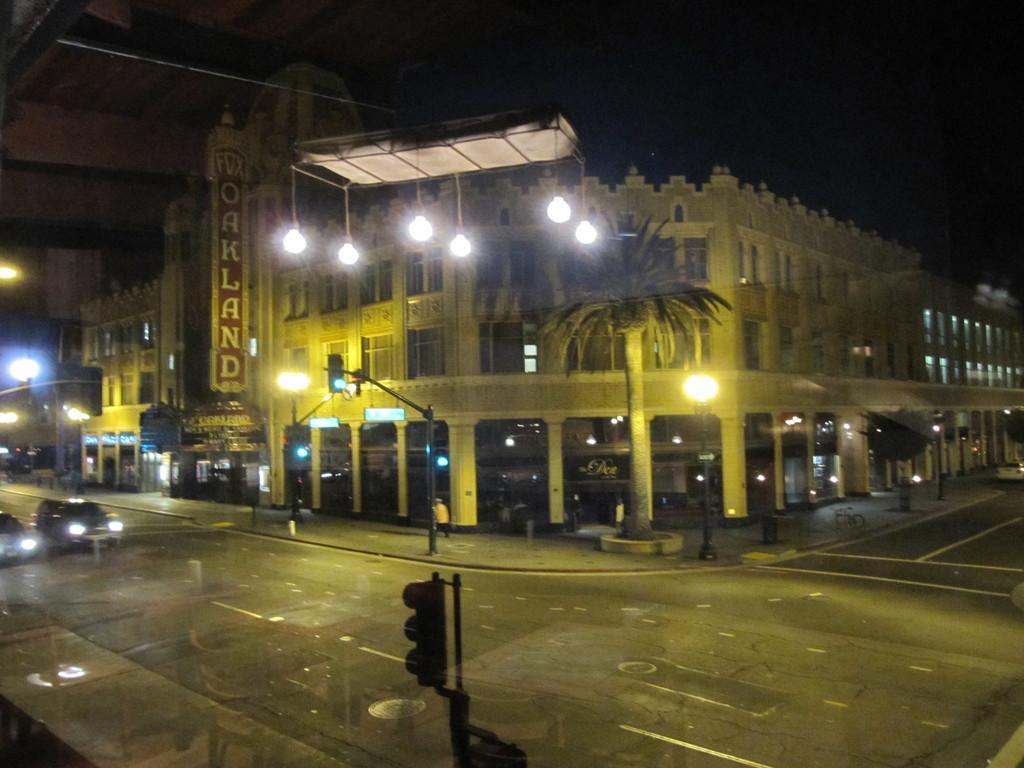In one or two sentences, can you explain what this image depicts? In the center of the image we can see buildings, boards, lights, tree, wall, windows are there. At the bottom of the image road is there. On the left side of the image cars are there. In the middle of the image a person is there. At the top of the image sky is there. 